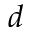<formula> <loc_0><loc_0><loc_500><loc_500>d</formula> 